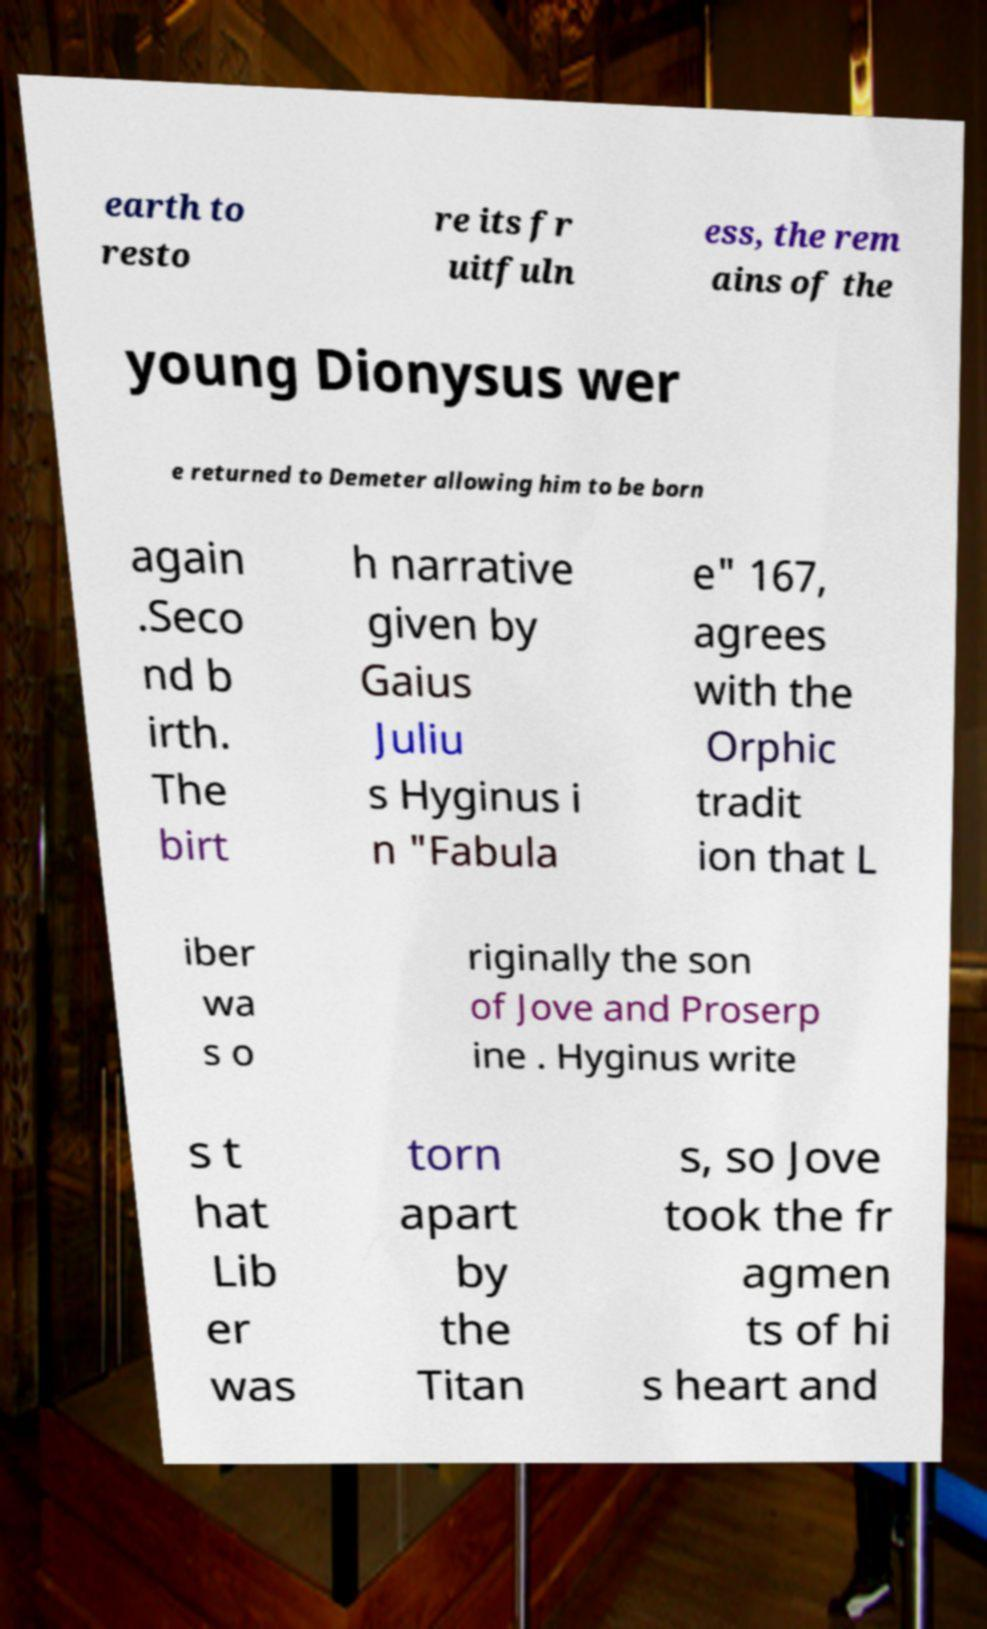There's text embedded in this image that I need extracted. Can you transcribe it verbatim? earth to resto re its fr uitfuln ess, the rem ains of the young Dionysus wer e returned to Demeter allowing him to be born again .Seco nd b irth. The birt h narrative given by Gaius Juliu s Hyginus i n "Fabula e" 167, agrees with the Orphic tradit ion that L iber wa s o riginally the son of Jove and Proserp ine . Hyginus write s t hat Lib er was torn apart by the Titan s, so Jove took the fr agmen ts of hi s heart and 